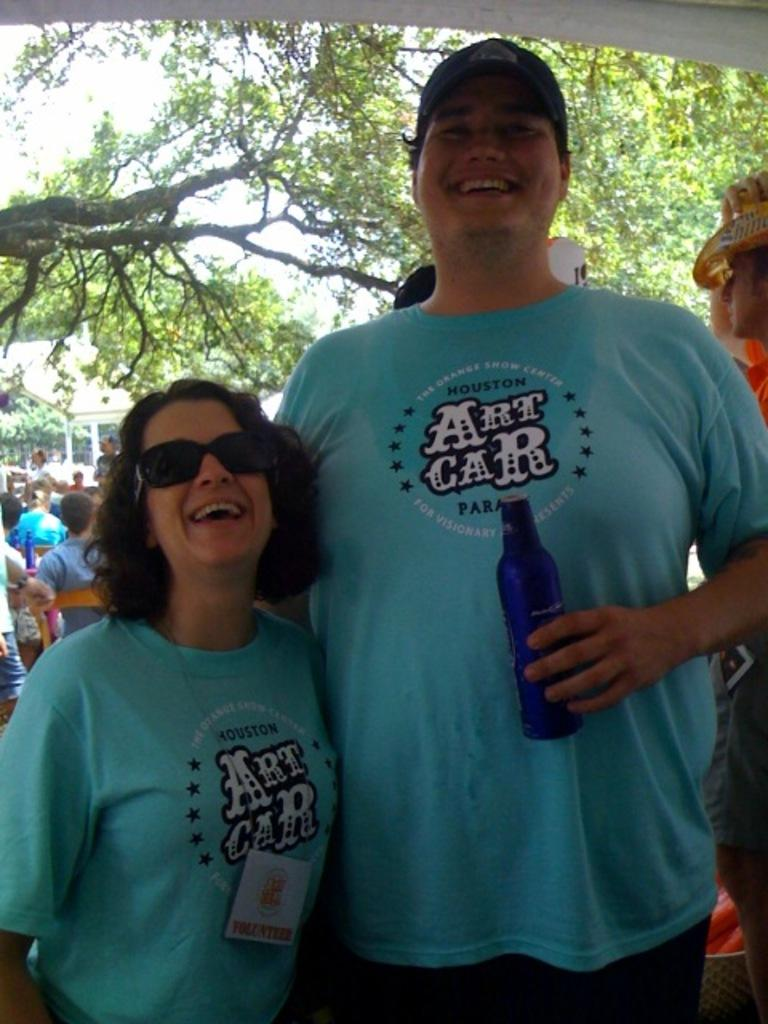How many people are present in the image? There are two people in the image, a woman and a man. What are the people in the image doing? Both the woman and the man are standing and smiling. What is the man holding in the image? The man is holding a bottle. What can be seen in the background of the image? There are people and trees in the background of the image. What type of book is the woman reading in the image? There is no book present in the image, and the woman is not reading. 